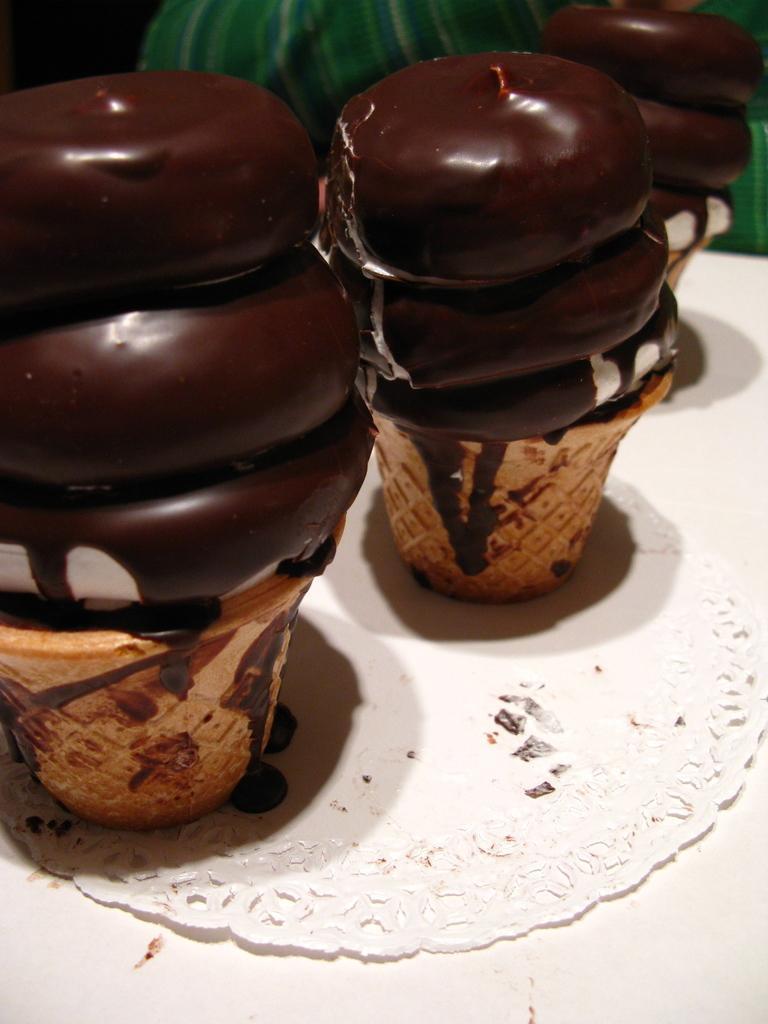In one or two sentences, can you explain what this image depicts? In this picture we can see a mat, food on the white surface and in the background we can see a cloth. 